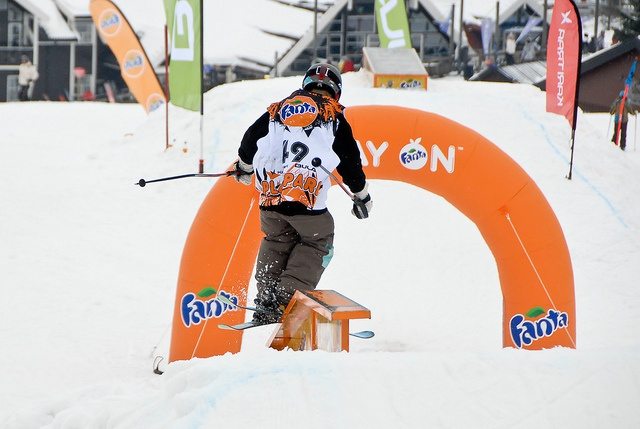Describe the objects in this image and their specific colors. I can see people in gray, black, lavender, and red tones, people in gray, lightgray, darkgray, and black tones, people in gray, black, and maroon tones, skis in gray, lightgray, lightblue, and darkgray tones, and people in gray, black, lightgray, and darkgray tones in this image. 